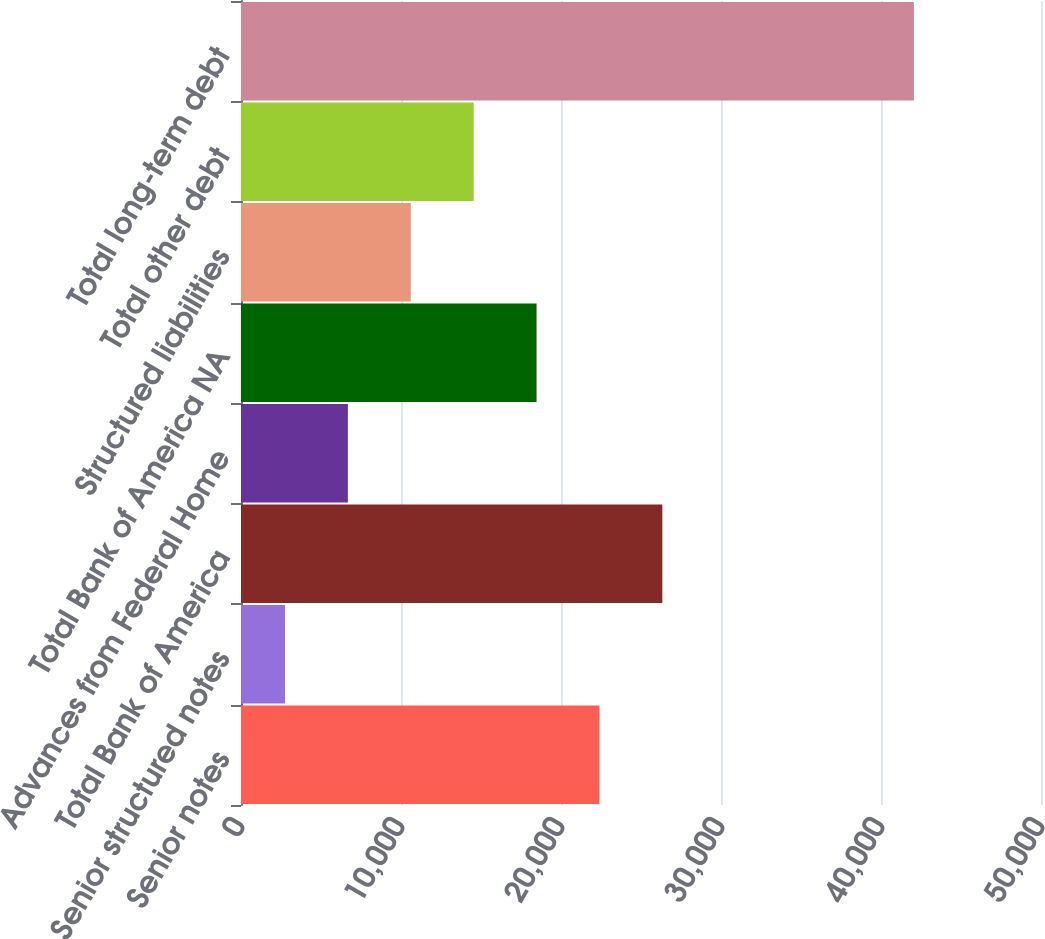Convert chart. <chart><loc_0><loc_0><loc_500><loc_500><bar_chart><fcel>Senior notes<fcel>Senior structured notes<fcel>Total Bank of America<fcel>Advances from Federal Home<fcel>Total Bank of America NA<fcel>Structured liabilities<fcel>Total other debt<fcel>Total long-term debt<nl><fcel>22403<fcel>2749<fcel>26333.8<fcel>6679.8<fcel>18472.2<fcel>10610.6<fcel>14541.4<fcel>42057<nl></chart> 